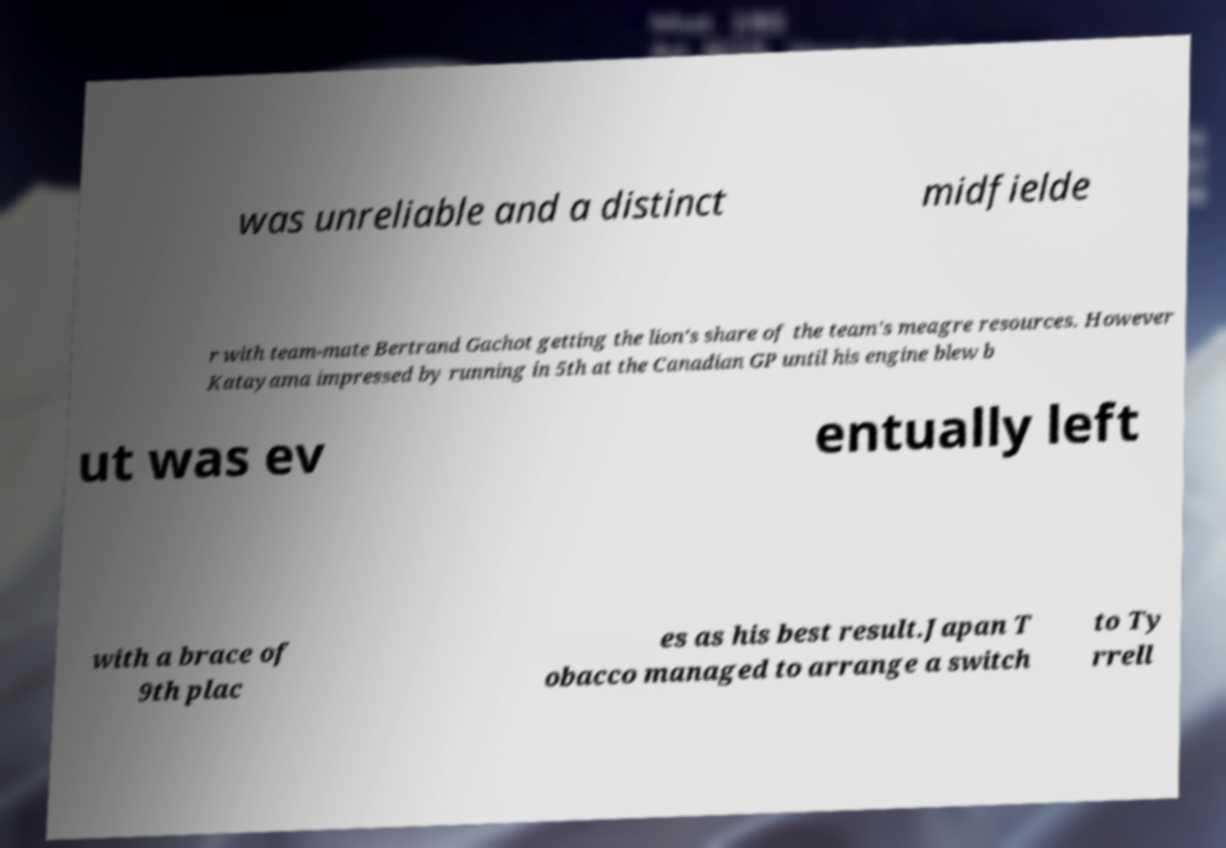What messages or text are displayed in this image? I need them in a readable, typed format. was unreliable and a distinct midfielde r with team-mate Bertrand Gachot getting the lion's share of the team's meagre resources. However Katayama impressed by running in 5th at the Canadian GP until his engine blew b ut was ev entually left with a brace of 9th plac es as his best result.Japan T obacco managed to arrange a switch to Ty rrell 